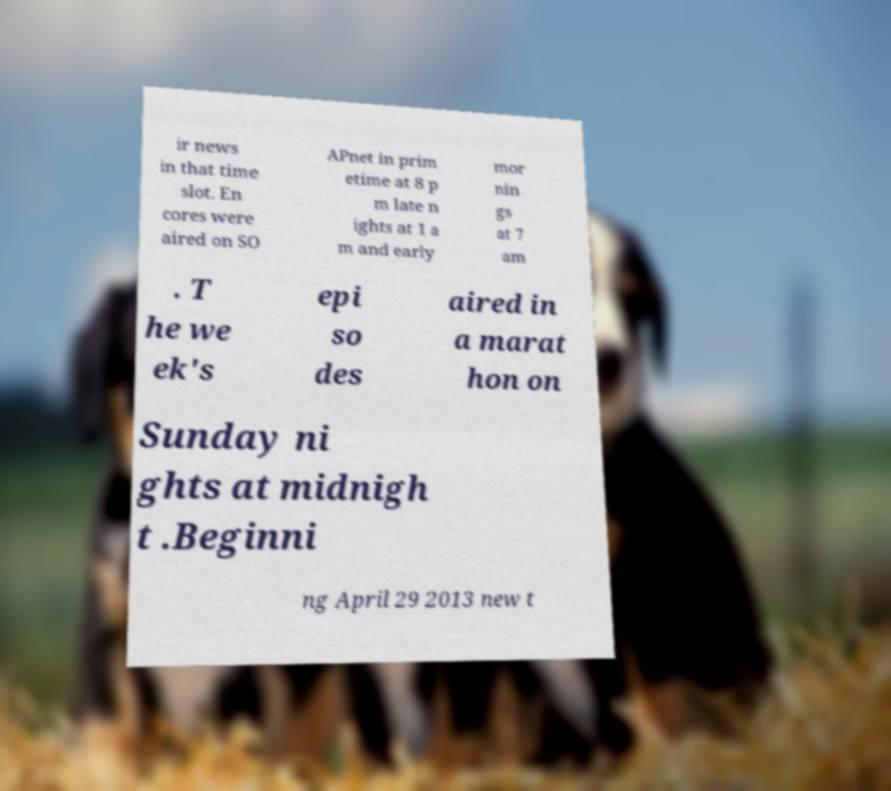Please identify and transcribe the text found in this image. ir news in that time slot. En cores were aired on SO APnet in prim etime at 8 p m late n ights at 1 a m and early mor nin gs at 7 am . T he we ek's epi so des aired in a marat hon on Sunday ni ghts at midnigh t .Beginni ng April 29 2013 new t 